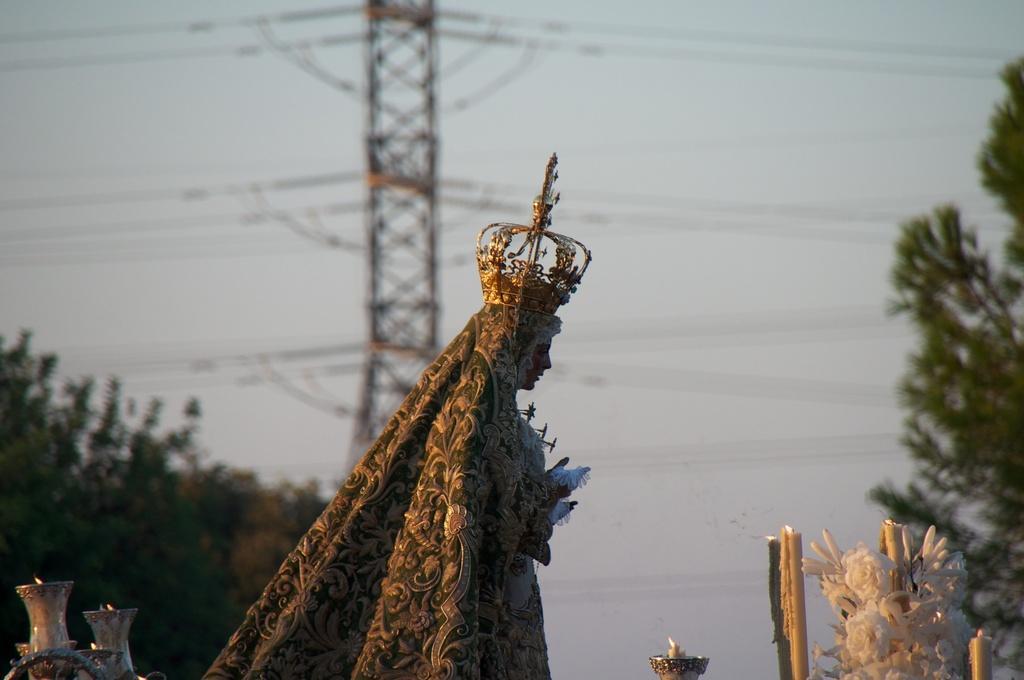Can you describe this image briefly? In the center of the image there is a statue. On the right side of the image we can see a tree. On the left side there is a tree. In the background there is a electricity tower, wires and sky. 